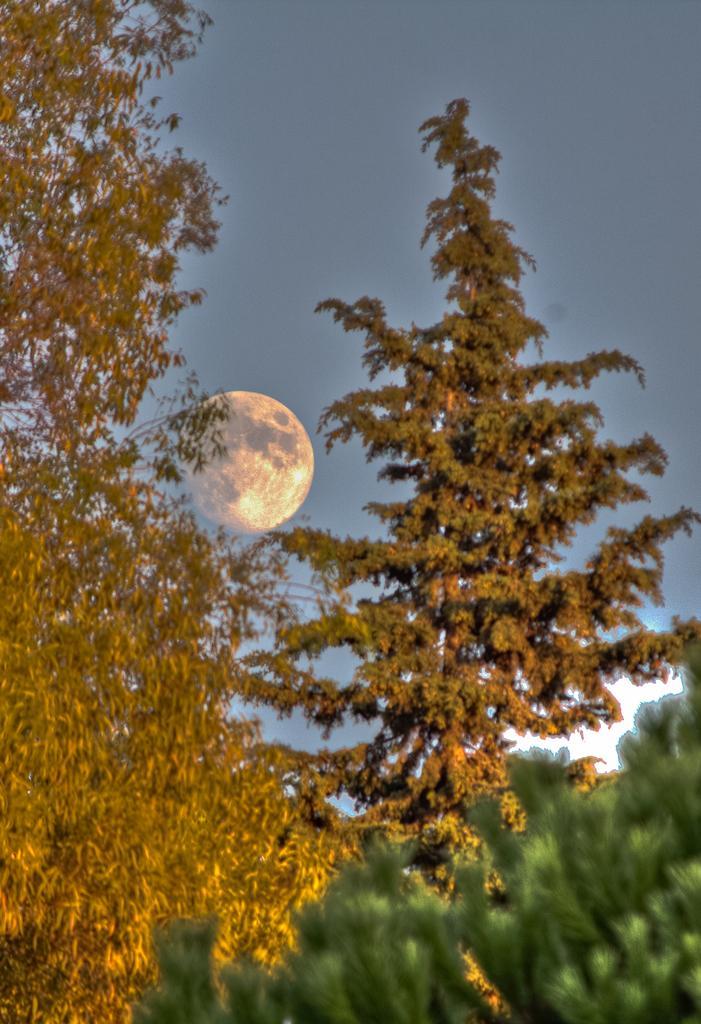Please provide a concise description of this image. This picture is clicked outside the city. In the center we can see the trees and a moon in the sky. In the background we can see the sky. 